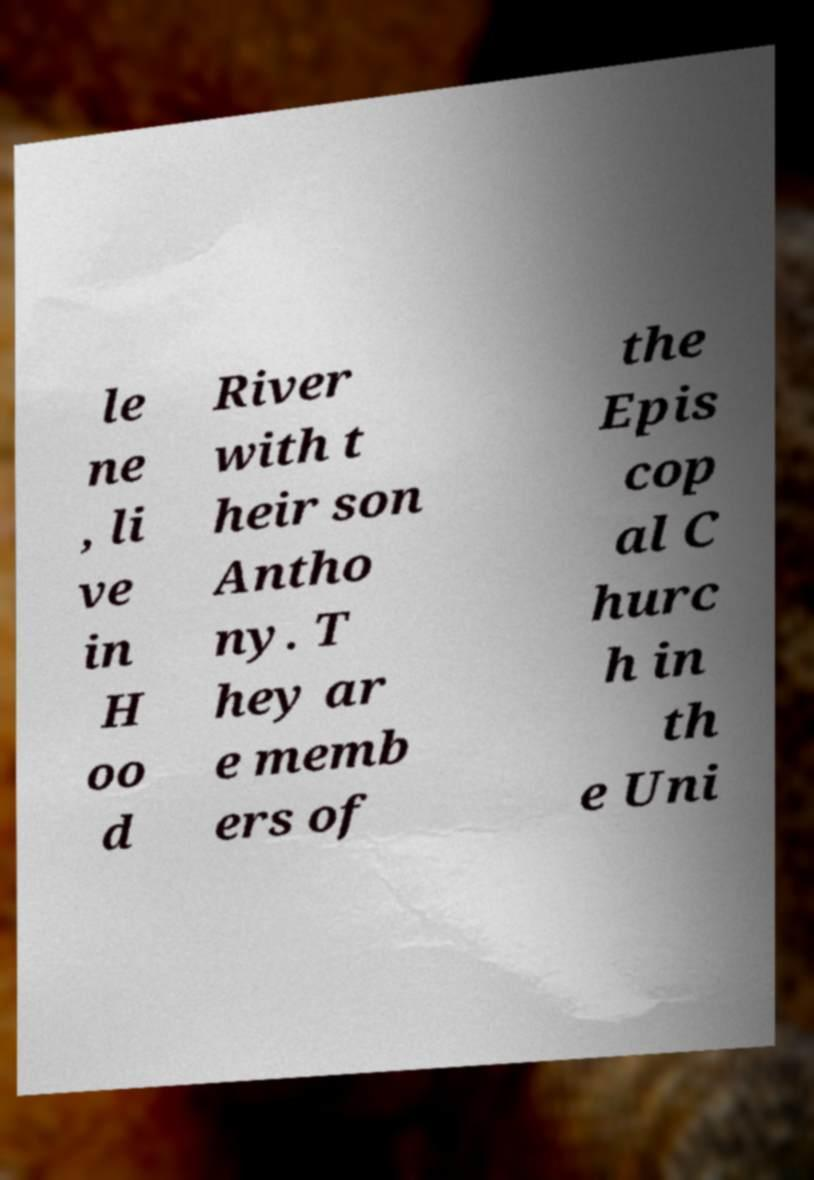Could you extract and type out the text from this image? le ne , li ve in H oo d River with t heir son Antho ny. T hey ar e memb ers of the Epis cop al C hurc h in th e Uni 